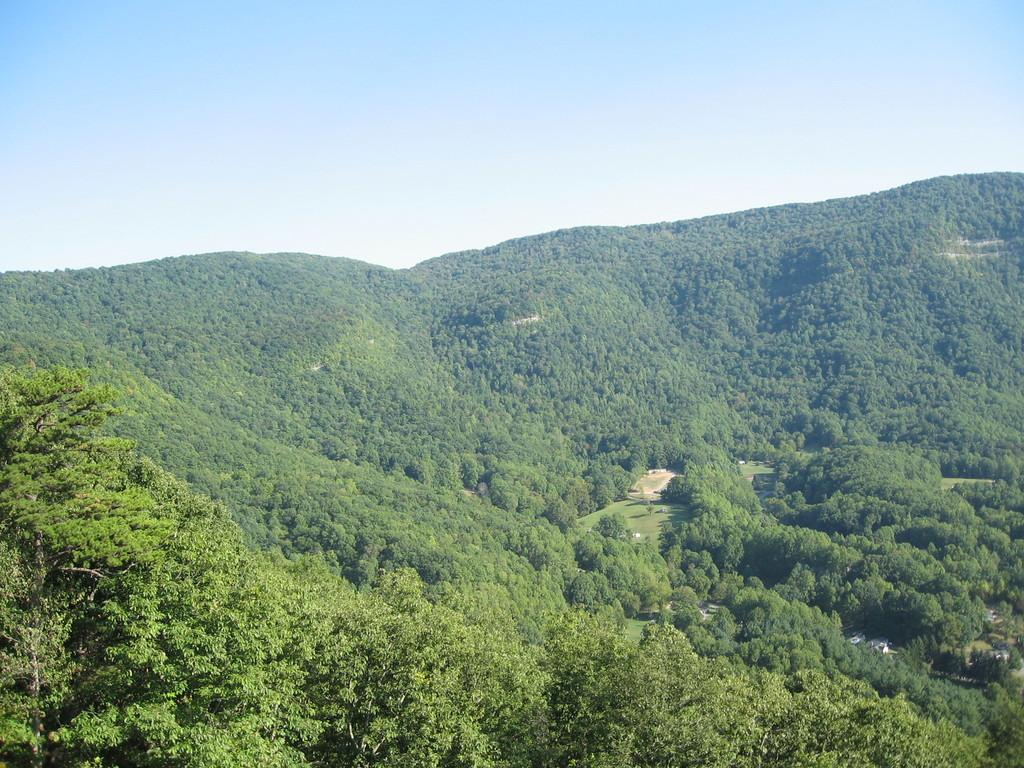What type of vegetation can be seen in the image? There are trees in the image. What type of structures are present in the image? There are houses in the image. What is the ground covered with in the image? There is grass visible in the image. What type of natural landform can be seen in the image? There are mountains in the image. What is visible in the sky in the image? There are clouds visible in the sky in the image. Where is the vase located in the image? There is no vase present in the image. Is there a bath visible in the image? There is no bath visible in the image. 